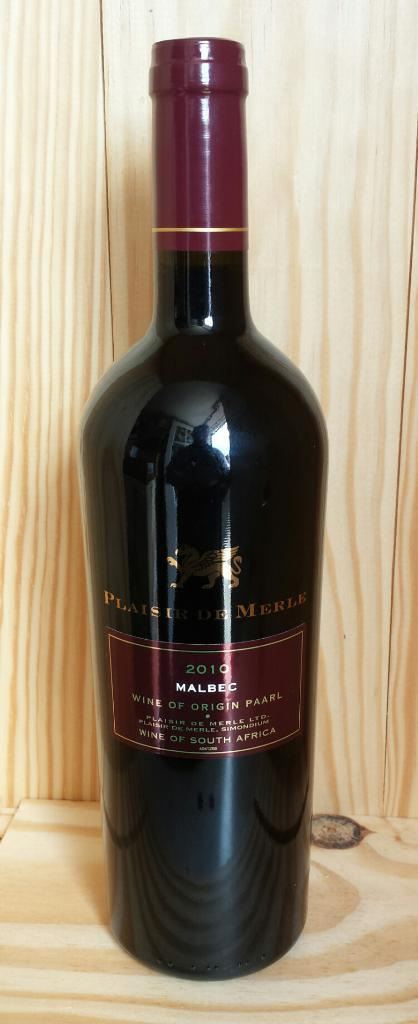<image>
Write a terse but informative summary of the picture. A dark colored bottle of Malbec wine of origin Paarl from 2010 with a dark red shiny label and gold lettering. 